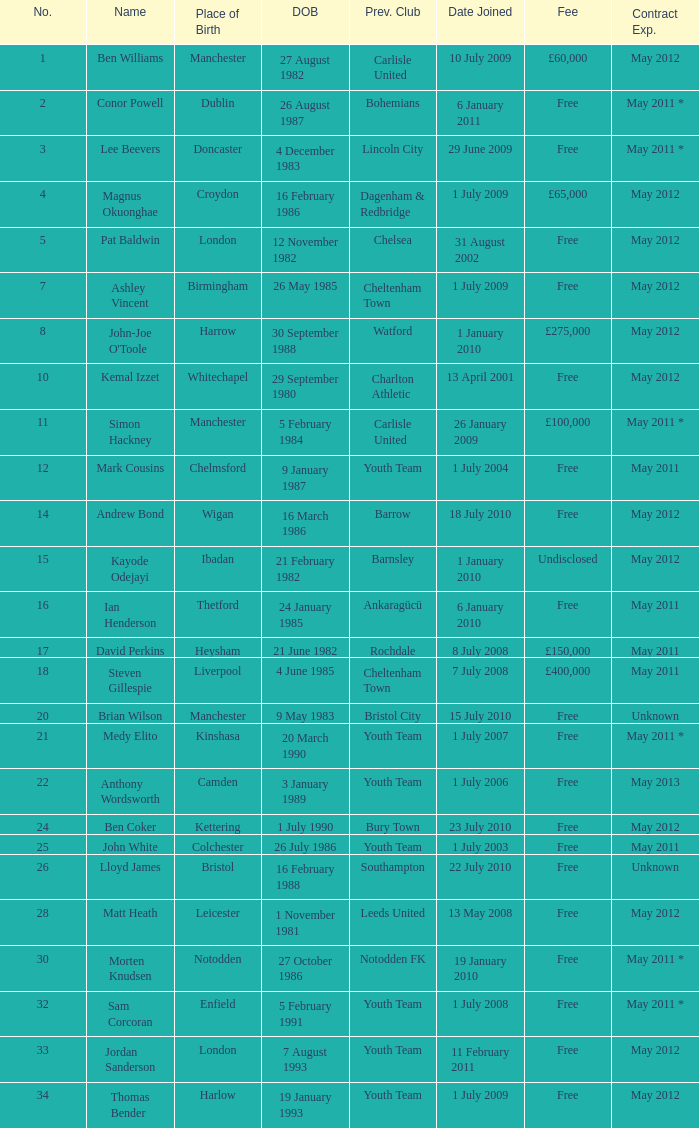For the no. 7 what is the date of birth 26 May 1985. 